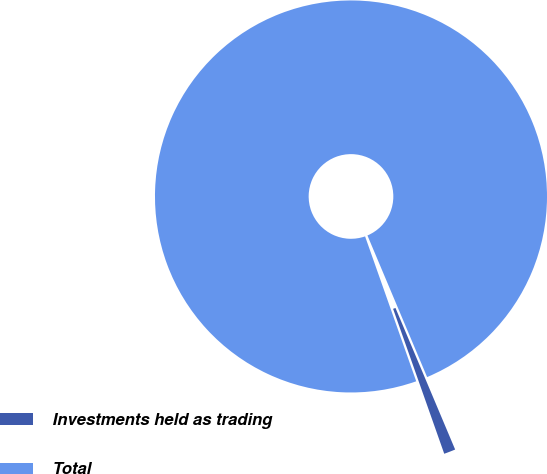Convert chart. <chart><loc_0><loc_0><loc_500><loc_500><pie_chart><fcel>Investments held as trading<fcel>Total<nl><fcel>0.95%<fcel>99.05%<nl></chart> 